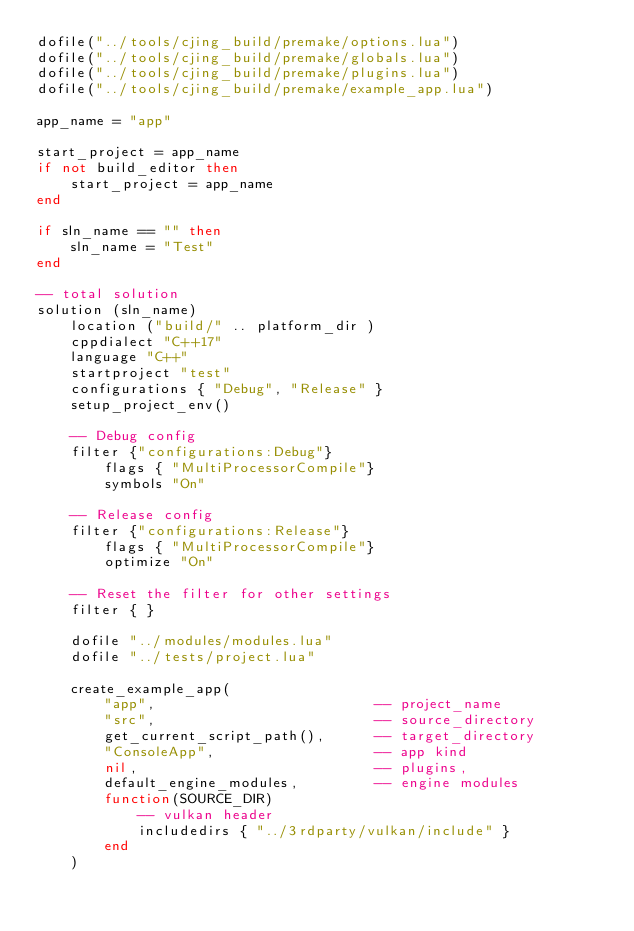Convert code to text. <code><loc_0><loc_0><loc_500><loc_500><_Lua_>dofile("../tools/cjing_build/premake/options.lua")
dofile("../tools/cjing_build/premake/globals.lua")
dofile("../tools/cjing_build/premake/plugins.lua")
dofile("../tools/cjing_build/premake/example_app.lua")

app_name = "app"

start_project = app_name
if not build_editor then 
    start_project = app_name
end 

if sln_name == "" then 
    sln_name = "Test"
end 

-- total solution
solution (sln_name)
    location ("build/" .. platform_dir ) 
    cppdialect "C++17"
    language "C++"
    startproject "test"
    configurations { "Debug", "Release" }
    setup_project_env()

    -- Debug config
    filter {"configurations:Debug"}
        flags { "MultiProcessorCompile"}
        symbols "On"

    -- Release config
    filter {"configurations:Release"}
        flags { "MultiProcessorCompile"}
        optimize "On"

    -- Reset the filter for other settings
    filter { }
    
    dofile "../modules/modules.lua"
    dofile "../tests/project.lua"

    create_example_app(
        "app",                          -- project_name
        "src",                          -- source_directory
        get_current_script_path(),      -- target_directory
        "ConsoleApp",                   -- app kind
        nil,                            -- plugins,
        default_engine_modules,         -- engine modules
        function(SOURCE_DIR)
            -- vulkan header
            includedirs { "../3rdparty/vulkan/include" }
        end
    )</code> 